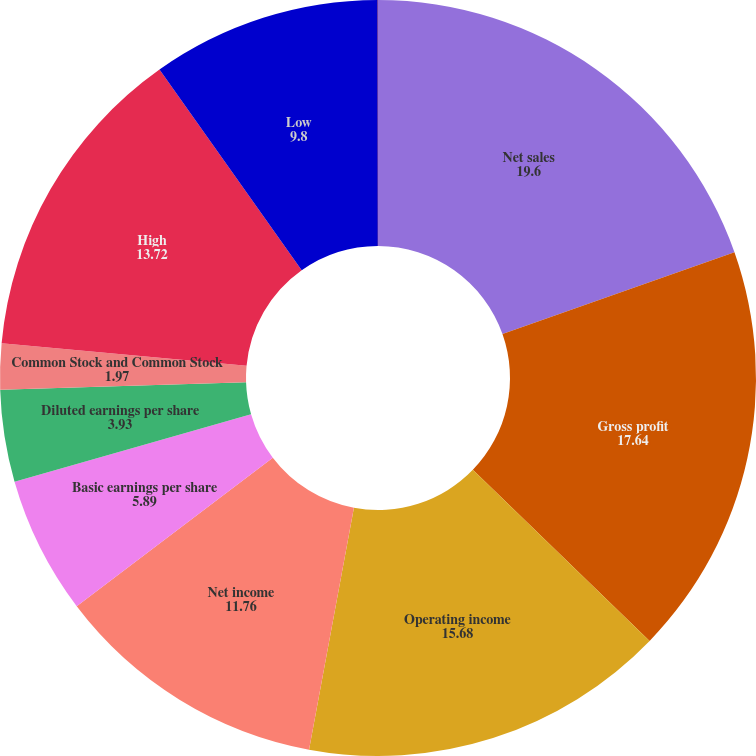Convert chart. <chart><loc_0><loc_0><loc_500><loc_500><pie_chart><fcel>Net sales<fcel>Gross profit<fcel>Operating income<fcel>Net income<fcel>Basic earnings per share<fcel>Diluted earnings per share<fcel>Common Stock and Common Stock<fcel>High<fcel>Low<fcel>Dividends declared per share-<nl><fcel>19.6%<fcel>17.64%<fcel>15.68%<fcel>11.76%<fcel>5.89%<fcel>3.93%<fcel>1.97%<fcel>13.72%<fcel>9.8%<fcel>0.01%<nl></chart> 